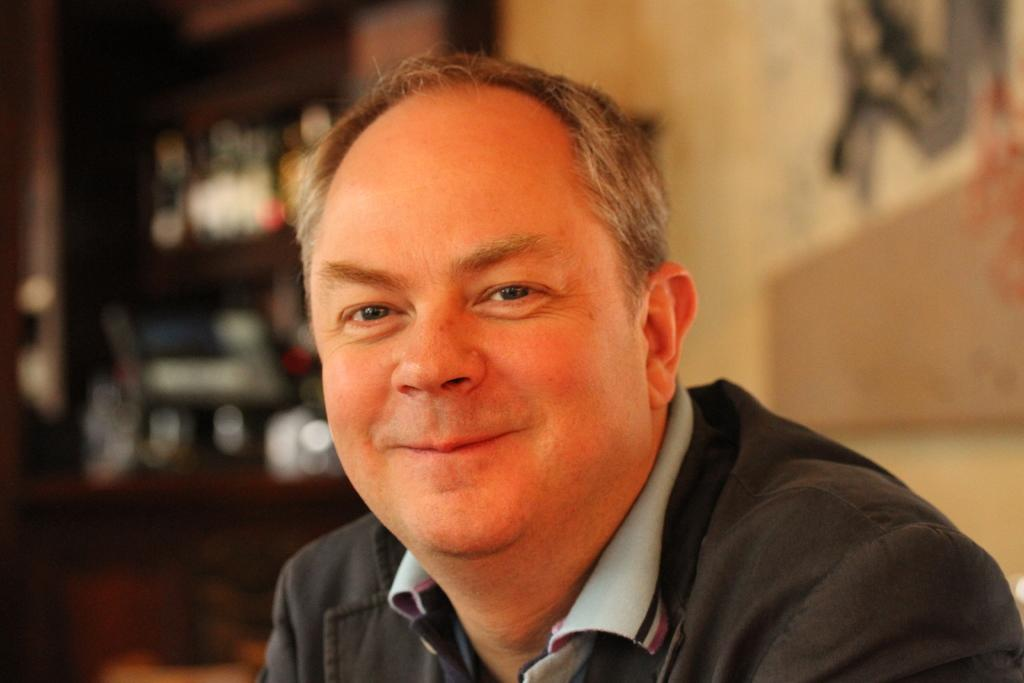What is the main subject of the image? There is a person in the image. What colors is the person wearing? The person is wearing black, ash, and pink colors. What can be seen in the background of the image? There is a wall in the background of the image. How would you describe the appearance of the background? The background appears blurred. What type of salt can be seen on the person's clothing in the image? There is no salt visible on the person's clothing in the image. Can you tell me how many pickles are on the wall in the image? There are no pickles present in the image; it only features a person and a wall in the background. 